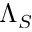Convert formula to latex. <formula><loc_0><loc_0><loc_500><loc_500>\Lambda _ { S }</formula> 